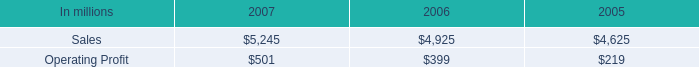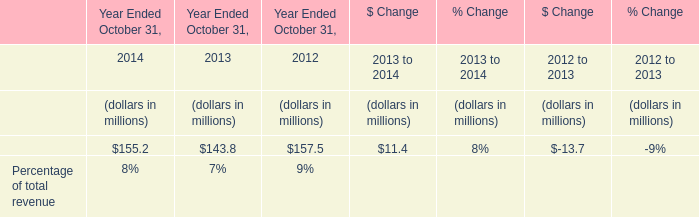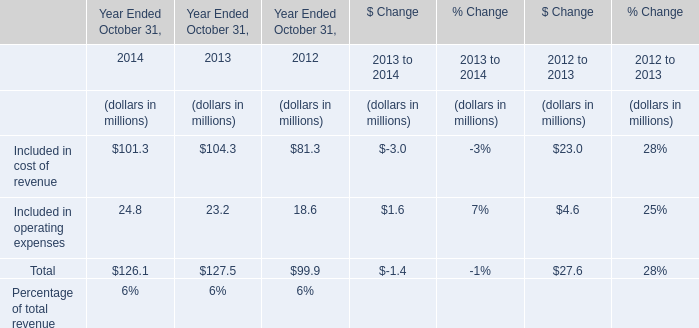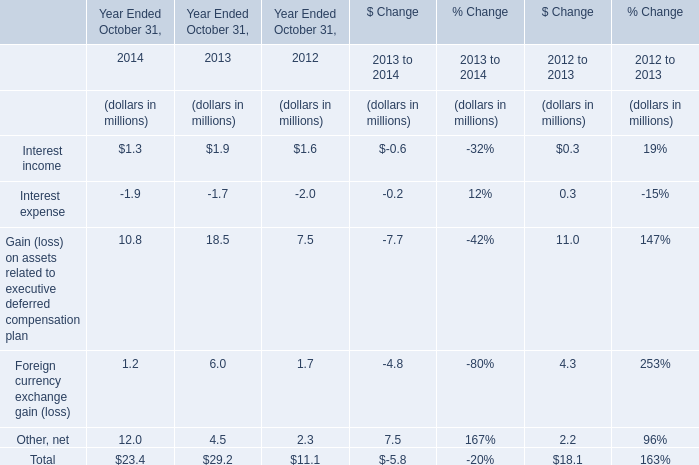Which year is Interest income greater than 1 Year Ended October 31,? 
Answer: 2014 2013 2012. 